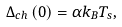<formula> <loc_0><loc_0><loc_500><loc_500>\Delta _ { c h } \left ( { 0 } \right ) = \alpha k _ { B } T _ { s } ,</formula> 